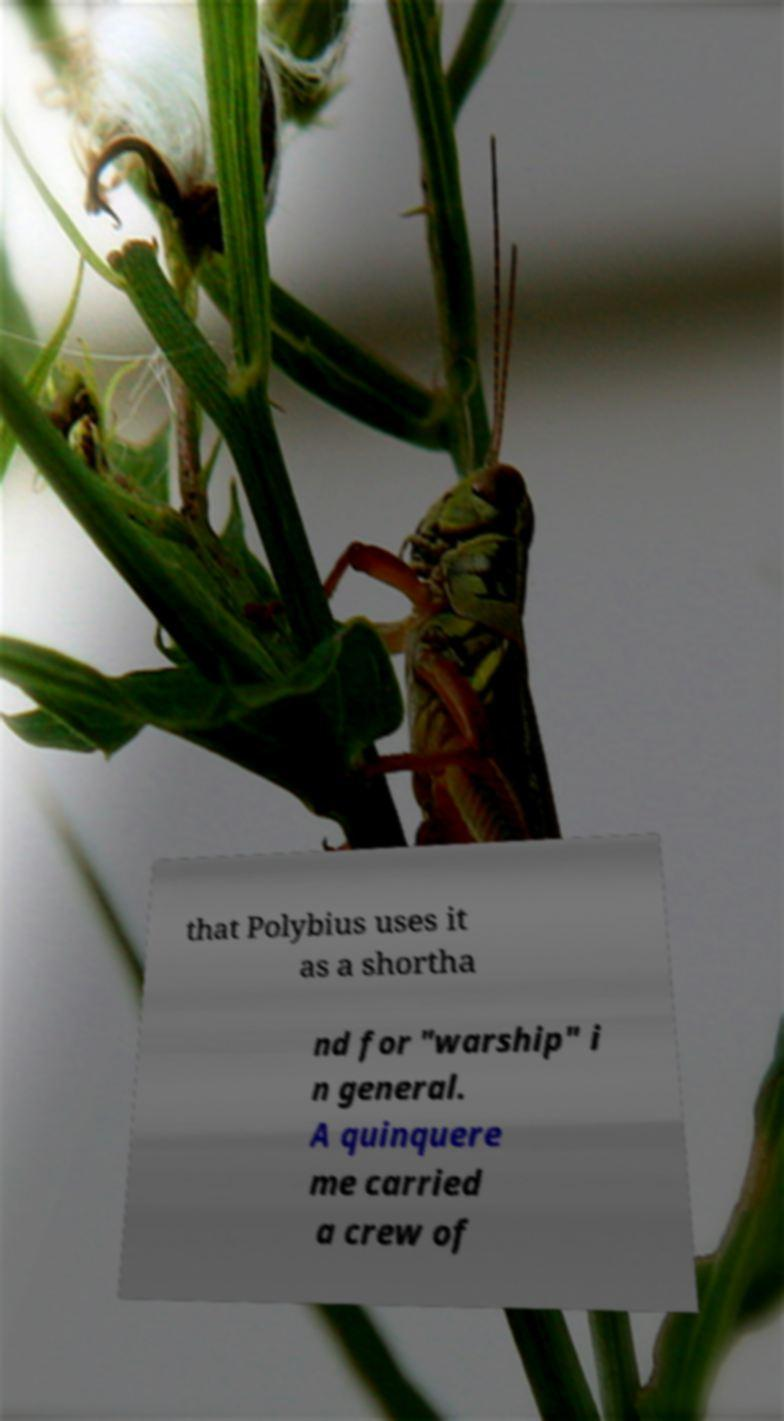I need the written content from this picture converted into text. Can you do that? that Polybius uses it as a shortha nd for "warship" i n general. A quinquere me carried a crew of 